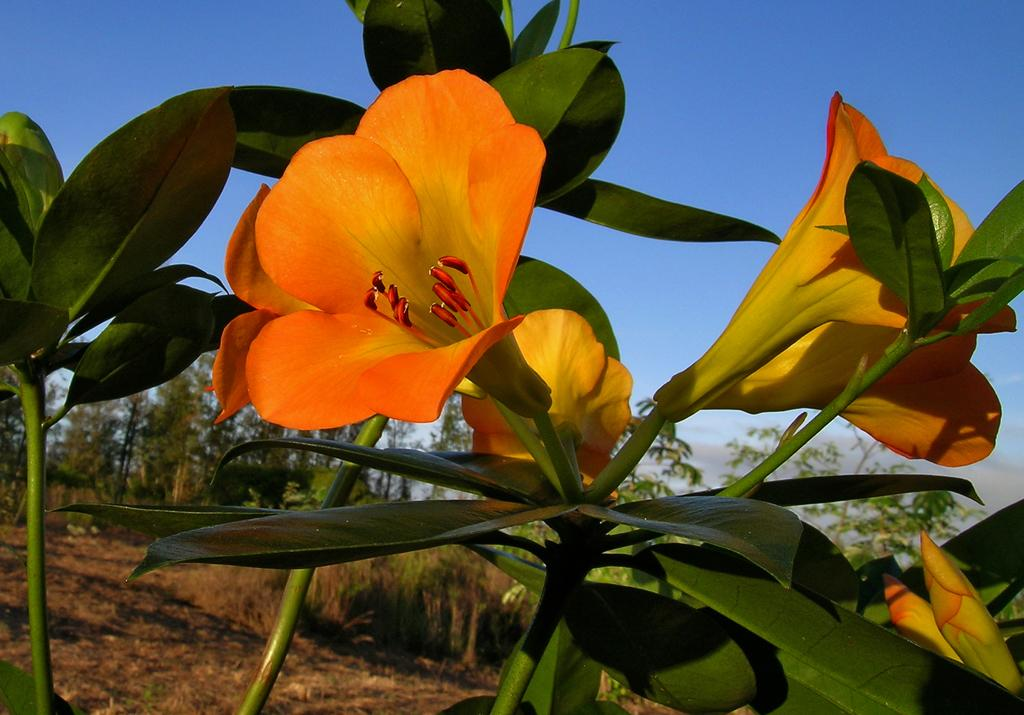What is the main subject of the image? The main subject of the image is flower plants. Where are the flower plants located in the image? The flower plants are in the center of the image. What can be seen in the background of the image? There are trees in the background of the image. What color is the crayon used to draw the rod in the image? There is no crayon, rod, or drawing present in the image; it features flower plants and trees in the background. 